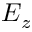Convert formula to latex. <formula><loc_0><loc_0><loc_500><loc_500>E _ { z }</formula> 